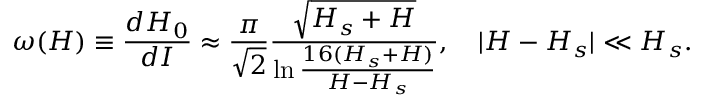<formula> <loc_0><loc_0><loc_500><loc_500>\omega ( H ) \equiv \frac { d H _ { 0 } } { d I } \approx \frac { \pi } { \sqrt { 2 } } \frac { \sqrt { H _ { s } + H } } { \ln { \frac { 1 6 ( H _ { s } + H ) } { H - H _ { s } } } } , \quad | H - H _ { s } | \ll H _ { s } .</formula> 